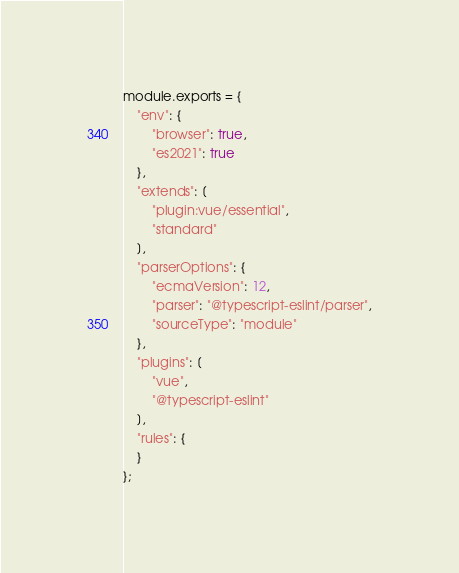Convert code to text. <code><loc_0><loc_0><loc_500><loc_500><_JavaScript_>module.exports = {
    "env": {
        "browser": true,
        "es2021": true
    },
    "extends": [
        "plugin:vue/essential",
        "standard"
    ],
    "parserOptions": {
        "ecmaVersion": 12,
        "parser": "@typescript-eslint/parser",
        "sourceType": "module"
    },
    "plugins": [
        "vue",
        "@typescript-eslint"
    ],
    "rules": {
    }
};
</code> 